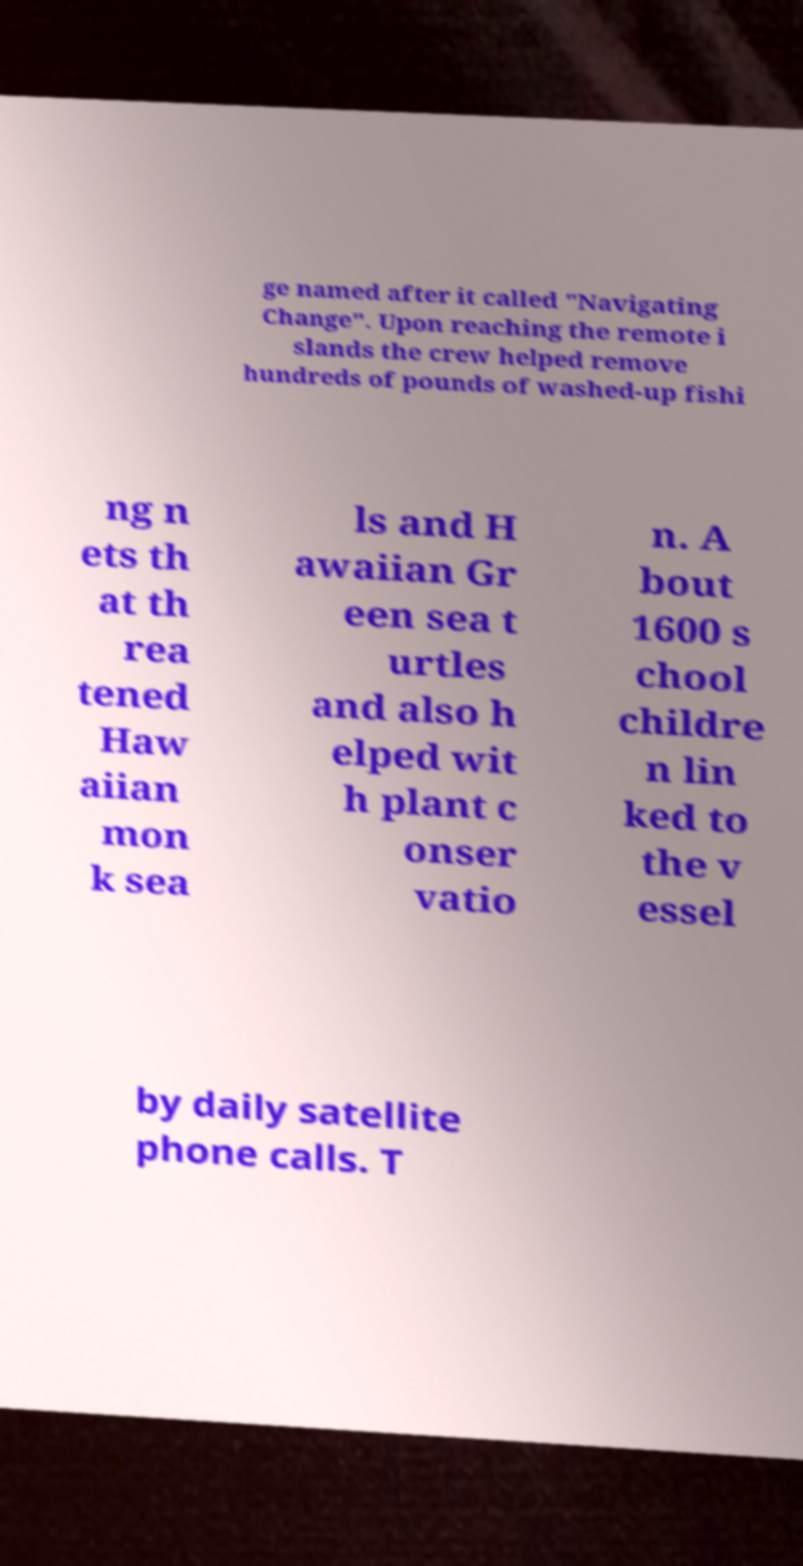There's text embedded in this image that I need extracted. Can you transcribe it verbatim? ge named after it called "Navigating Change". Upon reaching the remote i slands the crew helped remove hundreds of pounds of washed-up fishi ng n ets th at th rea tened Haw aiian mon k sea ls and H awaiian Gr een sea t urtles and also h elped wit h plant c onser vatio n. A bout 1600 s chool childre n lin ked to the v essel by daily satellite phone calls. T 